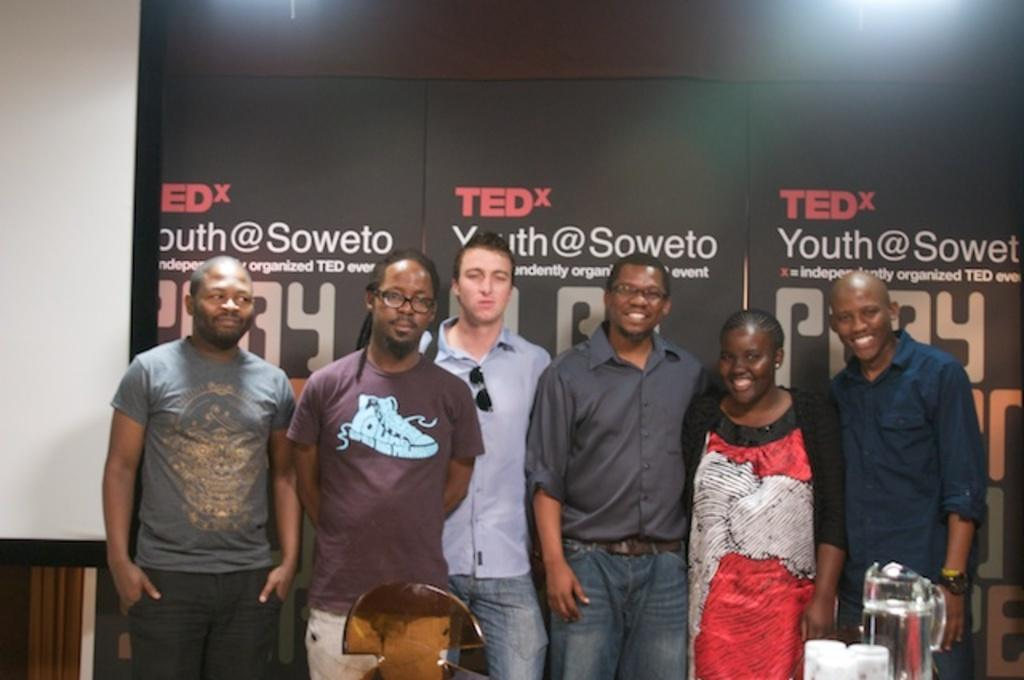How many people are present in the image? There are six persons standing in the image. Where are the persons standing? The persons are standing on the floor. What objects can be seen in the image besides the people? There are mugs and glasses in the image. What can be seen in the background of the image? There is a wall, lights, and hoardings in the background of the image. What type of location might the image have been taken in? The image may have been taken in a hall. What type of toad can be seen sleeping on the floor in the image? There is no toad present in the image, and therefore no such activity can be observed. 